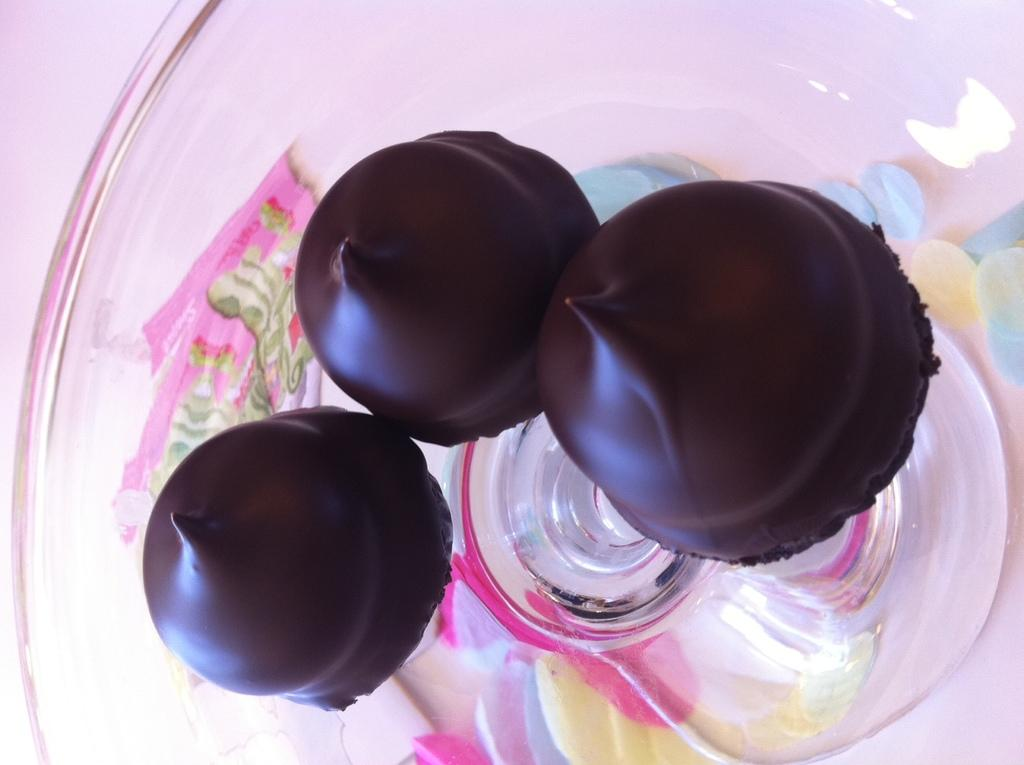What type of food is present in the image? There are chocolates in the image. Where are the chocolates located? The chocolates are placed on a table. What type of chair is visible in the image? There is no chair present in the image; it only features chocolates placed on a table. What material is the marble made of in the image? There is no marble present in the image; it only features chocolates placed on a table. 